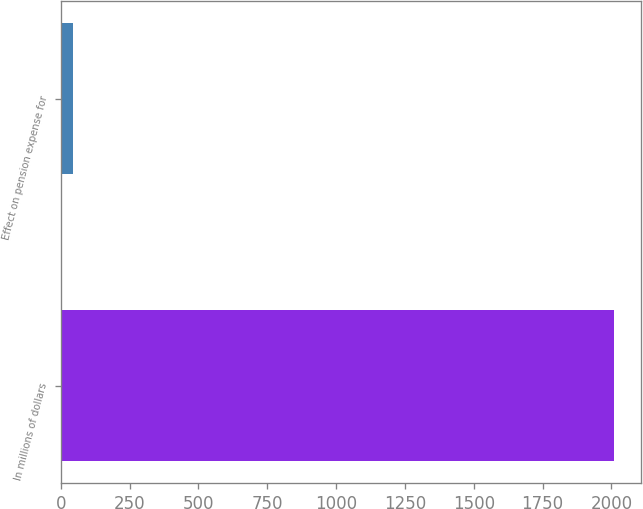Convert chart. <chart><loc_0><loc_0><loc_500><loc_500><bar_chart><fcel>In millions of dollars<fcel>Effect on pension expense for<nl><fcel>2009<fcel>44<nl></chart> 